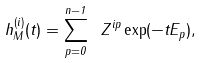Convert formula to latex. <formula><loc_0><loc_0><loc_500><loc_500>h _ { M } ^ { ( i ) } ( t ) = \sum _ { p = 0 } ^ { n - 1 } \ Z ^ { i p } \exp ( - t E _ { p } ) ,</formula> 